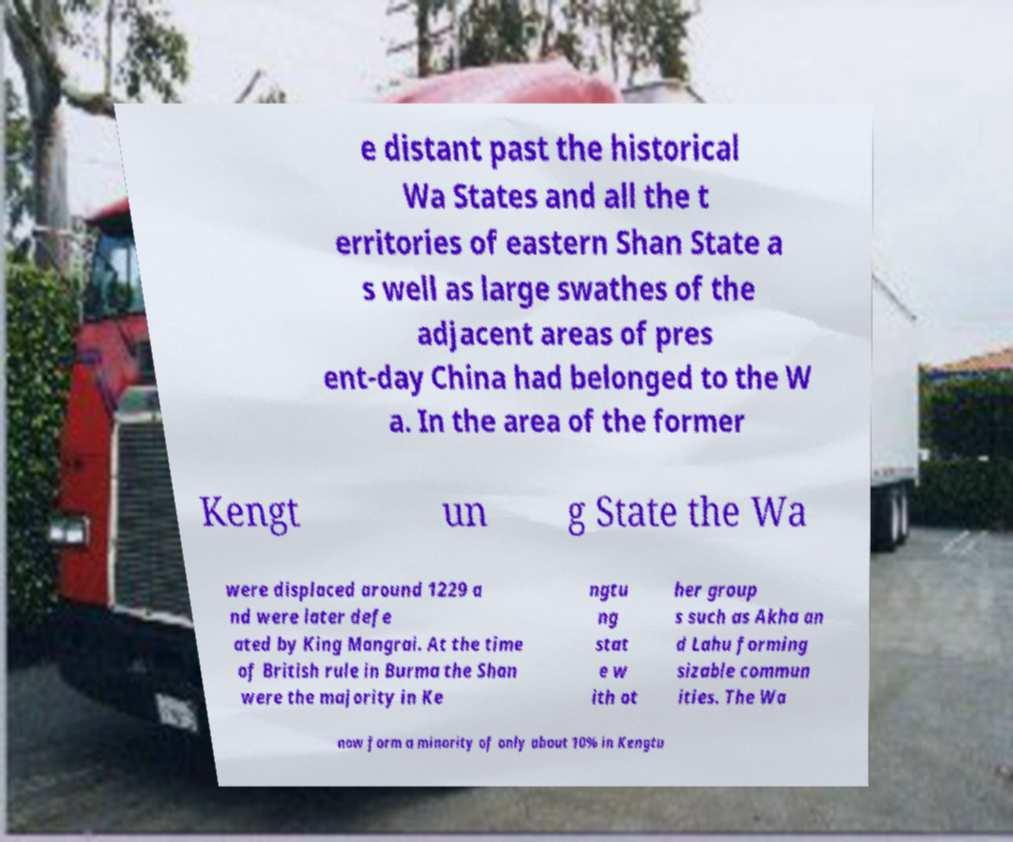I need the written content from this picture converted into text. Can you do that? e distant past the historical Wa States and all the t erritories of eastern Shan State a s well as large swathes of the adjacent areas of pres ent-day China had belonged to the W a. In the area of the former Kengt un g State the Wa were displaced around 1229 a nd were later defe ated by King Mangrai. At the time of British rule in Burma the Shan were the majority in Ke ngtu ng stat e w ith ot her group s such as Akha an d Lahu forming sizable commun ities. The Wa now form a minority of only about 10% in Kengtu 